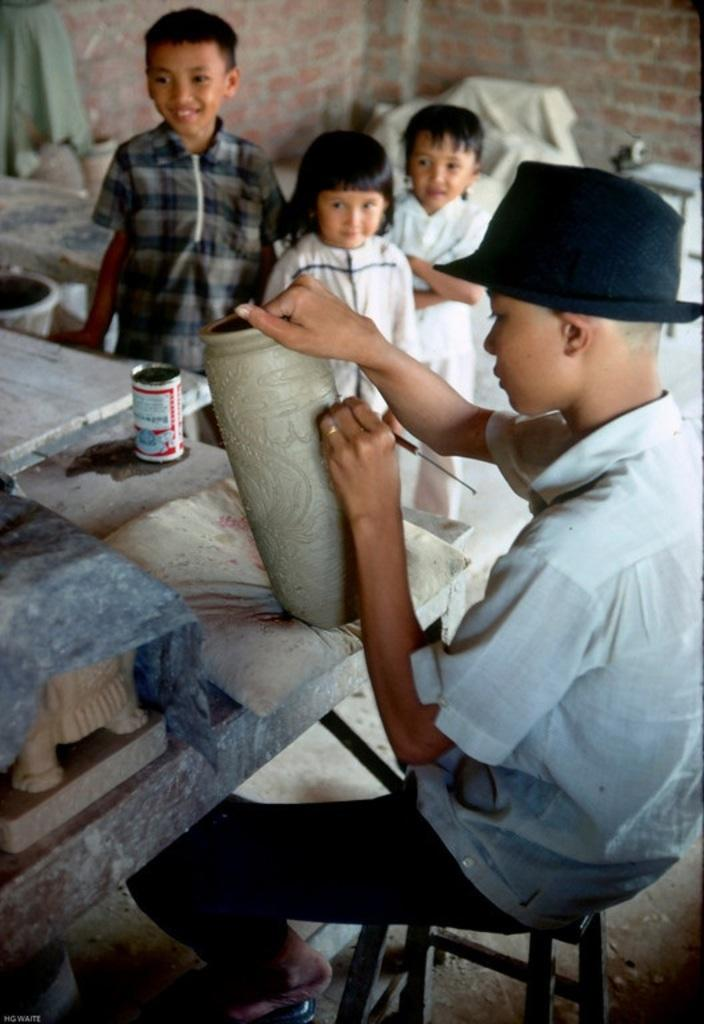Who is the main subject in the image? There is a boy in the image. What is the boy doing in the image? The boy is carving something in the image. Where is the boy located in the image? The boy is on the right side of the image. Are there any other children in the image? Yes, there are children in the image. Where are the other children located in the image? The children are at the top side of the image. How does the boy increase the size of the jar while carving in the image? There is no jar present in the image, and the boy is not shown increasing the size of anything while carving. 